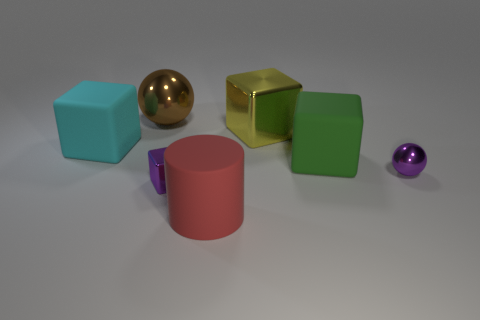What is the shape of the small object that is the same color as the tiny block?
Offer a very short reply. Sphere. What is the large block in front of the cyan matte block made of?
Your answer should be compact. Rubber. Is the number of brown balls on the left side of the cylinder the same as the number of large red cylinders that are right of the tiny purple metal cube?
Make the answer very short. Yes. There is a small thing that is the same shape as the big brown object; what is its color?
Ensure brevity in your answer.  Purple. Is there any other thing of the same color as the big shiny ball?
Make the answer very short. No. How many shiny objects are either green cubes or purple cylinders?
Give a very brief answer. 0. Is the rubber cylinder the same color as the large metallic cube?
Ensure brevity in your answer.  No. Is the number of yellow blocks behind the purple sphere greater than the number of big gray rubber objects?
Provide a short and direct response. Yes. What number of other objects are the same material as the yellow thing?
Provide a succinct answer. 3. What number of small things are cyan matte blocks or brown metal spheres?
Make the answer very short. 0. 